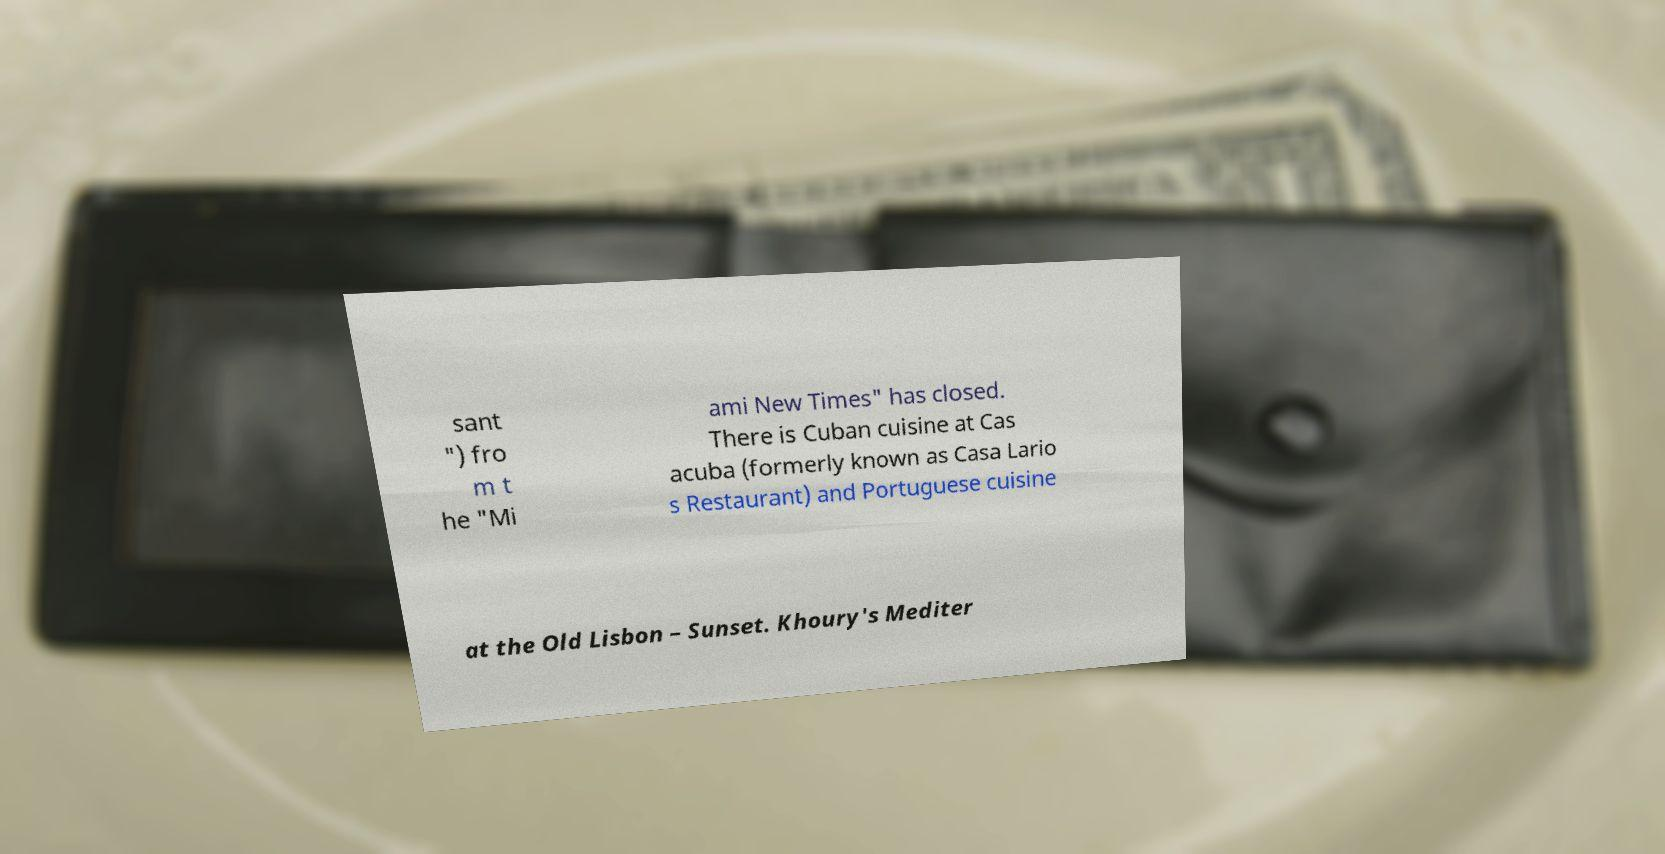What messages or text are displayed in this image? I need them in a readable, typed format. sant ") fro m t he "Mi ami New Times" has closed. There is Cuban cuisine at Cas acuba (formerly known as Casa Lario s Restaurant) and Portuguese cuisine at the Old Lisbon – Sunset. Khoury's Mediter 